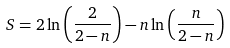<formula> <loc_0><loc_0><loc_500><loc_500>S = 2 \ln \left ( \frac { 2 } { 2 - n } \right ) - n \ln \left ( \frac { n } { 2 - n } \right )</formula> 